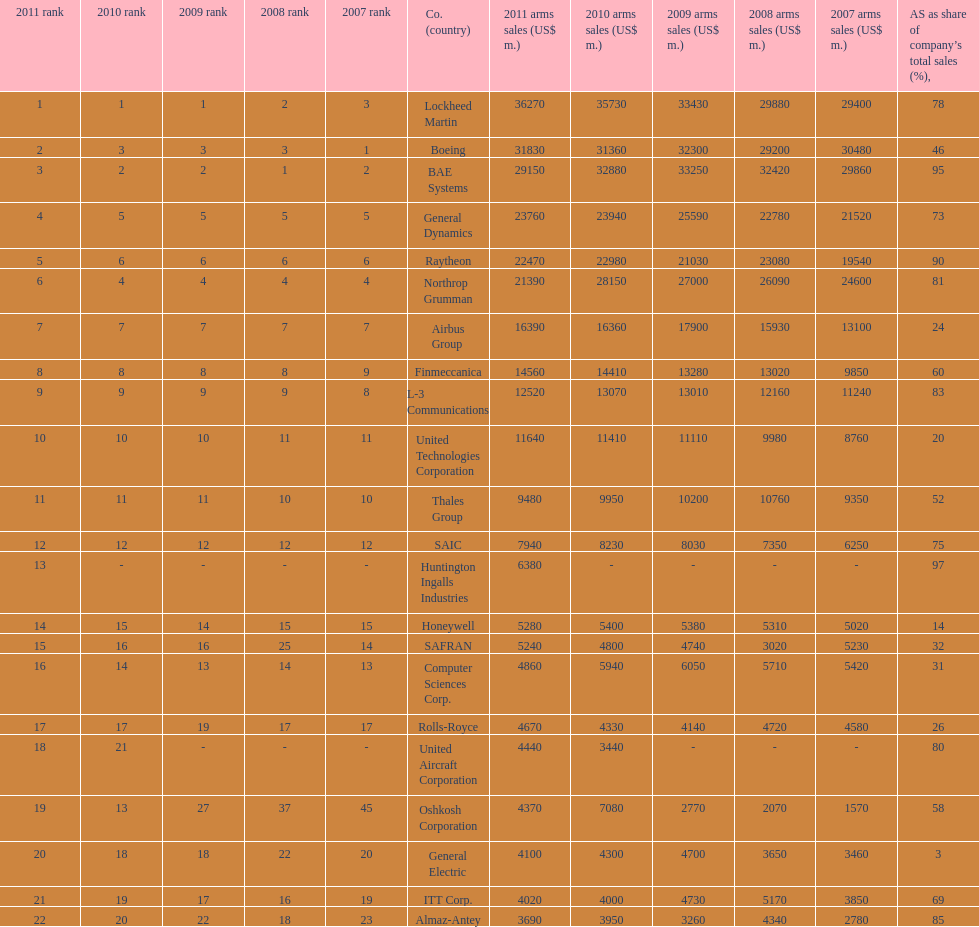What is the difference of the amount sold between boeing and general dynamics in 2007? 8960. 